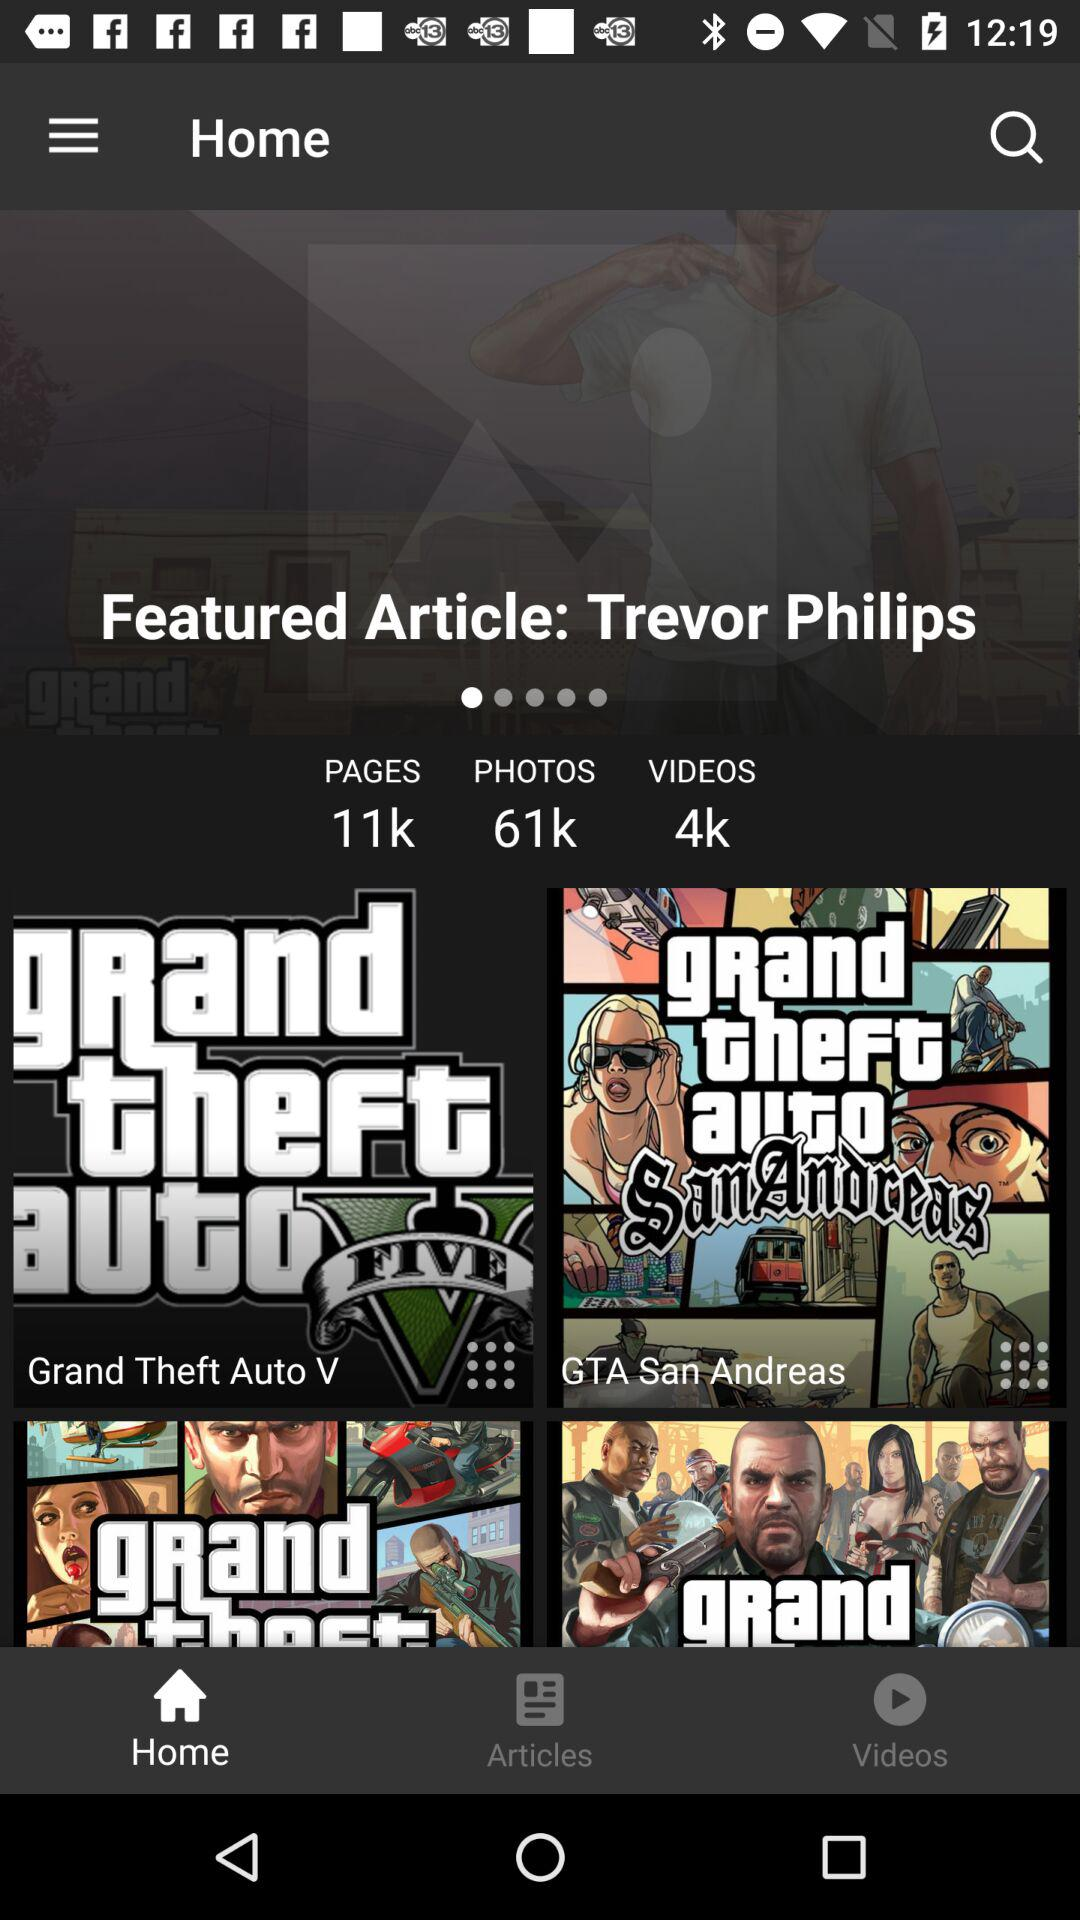What's the total number of photos? The total number of photos is 61k. 